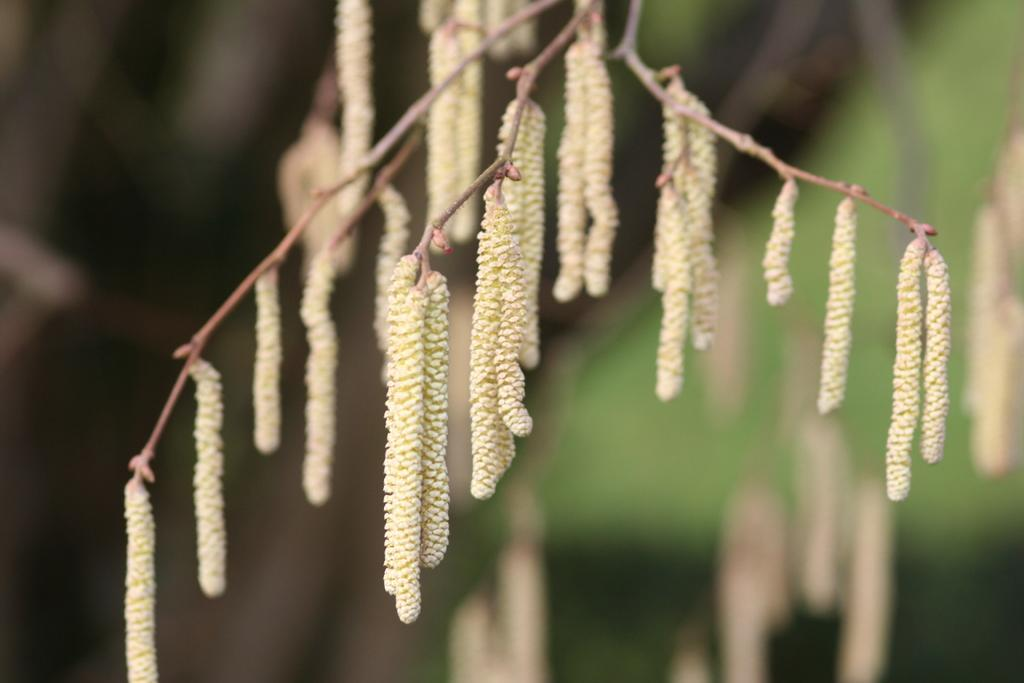What type of plant can be seen in the image? There is a flowering plant in the image. What force is causing the plant to levitate above the seashore in the image? There is no force causing the plant to levitate above the seashore in the image, as there is no seashore or levitation present. 